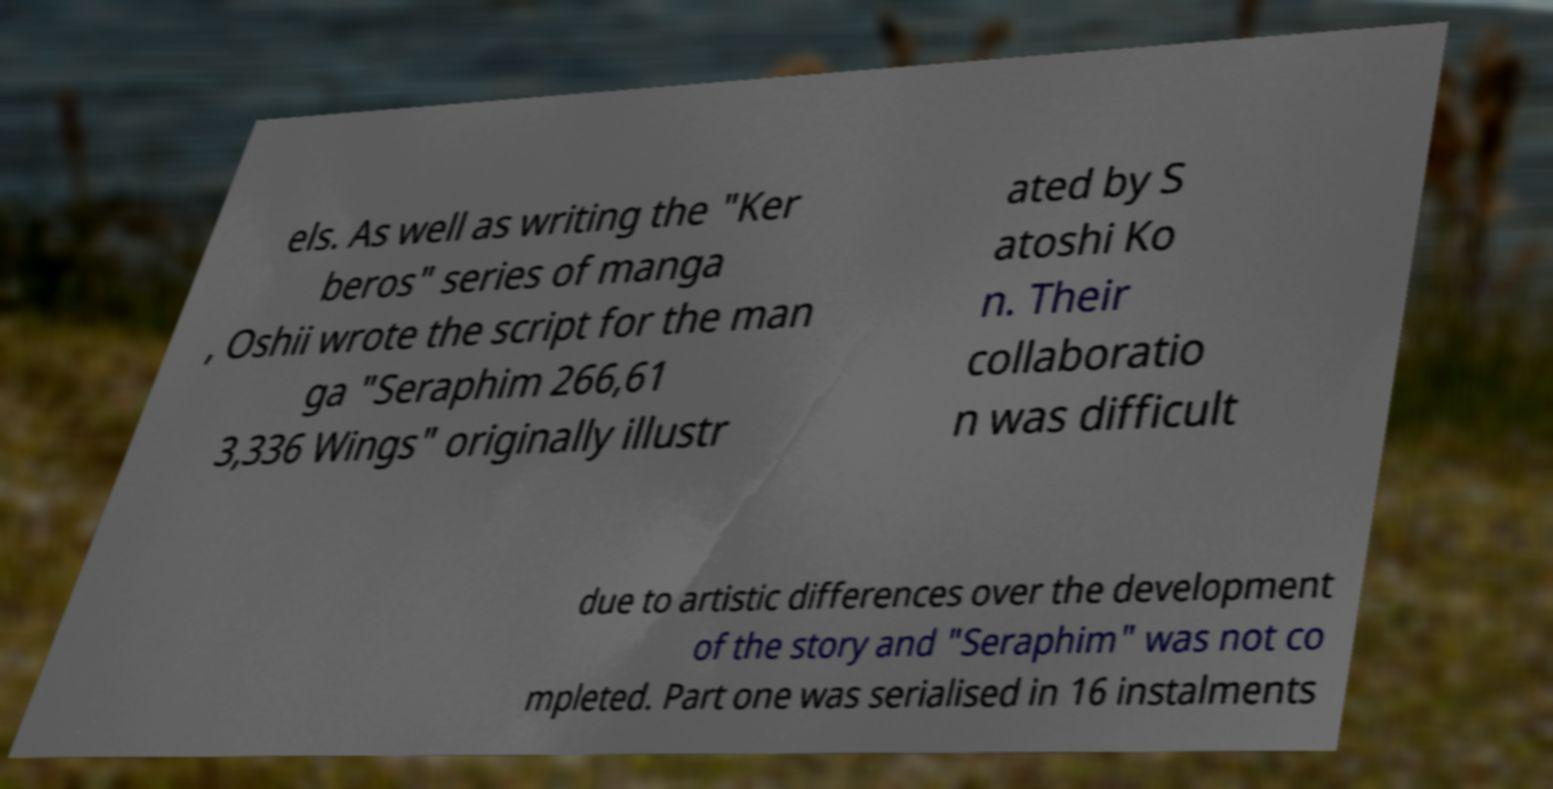Could you assist in decoding the text presented in this image and type it out clearly? els. As well as writing the "Ker beros" series of manga , Oshii wrote the script for the man ga "Seraphim 266,61 3,336 Wings" originally illustr ated by S atoshi Ko n. Their collaboratio n was difficult due to artistic differences over the development of the story and "Seraphim" was not co mpleted. Part one was serialised in 16 instalments 